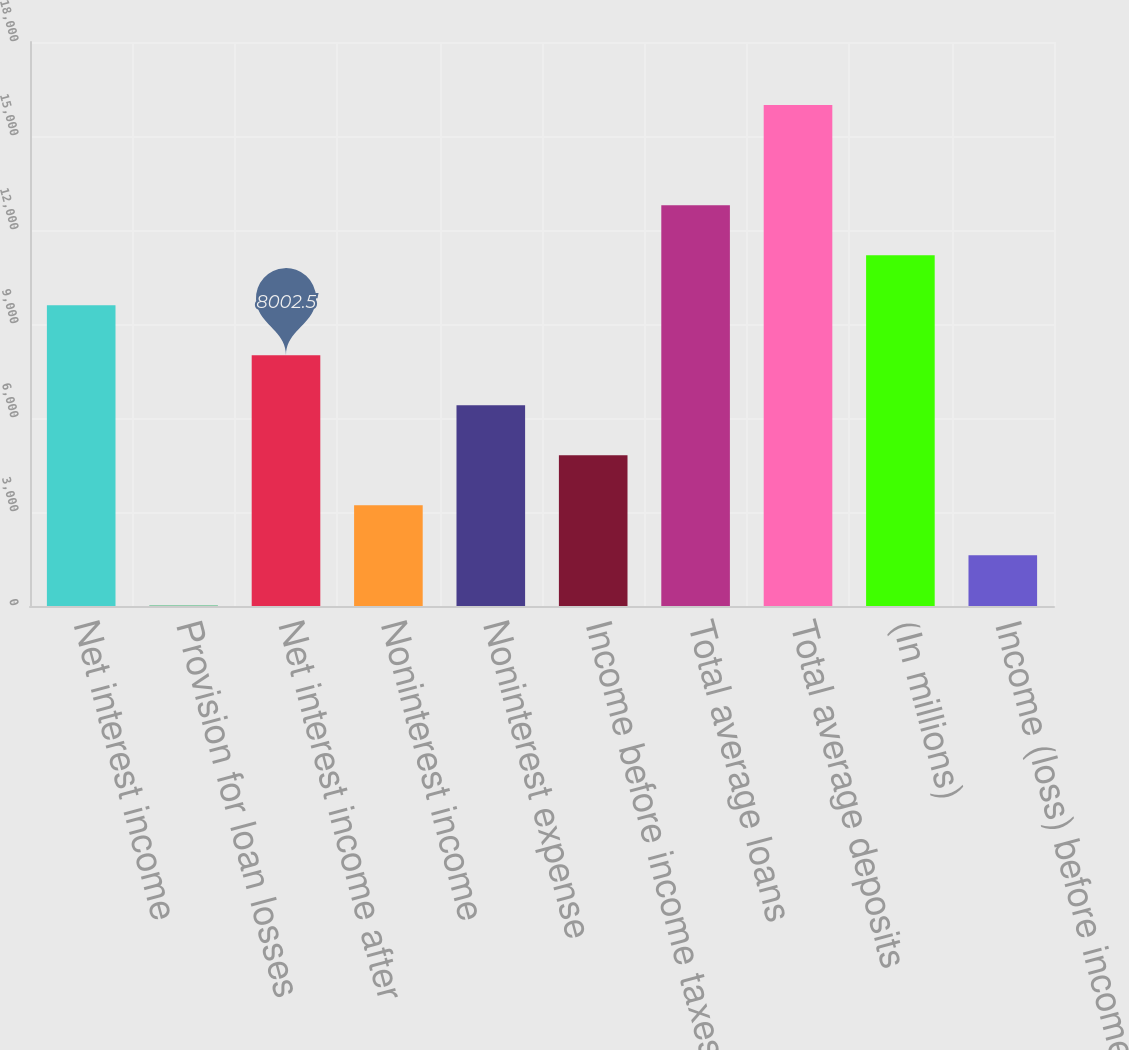<chart> <loc_0><loc_0><loc_500><loc_500><bar_chart><fcel>Net interest income<fcel>Provision for loan losses<fcel>Net interest income after<fcel>Noninterest income<fcel>Noninterest expense<fcel>Income before income taxes<fcel>Total average loans<fcel>Total average deposits<fcel>(In millions)<fcel>Income (loss) before income<nl><fcel>9599.2<fcel>19<fcel>8002.5<fcel>3212.4<fcel>6405.8<fcel>4809.1<fcel>12792.6<fcel>15986<fcel>11195.9<fcel>1615.7<nl></chart> 